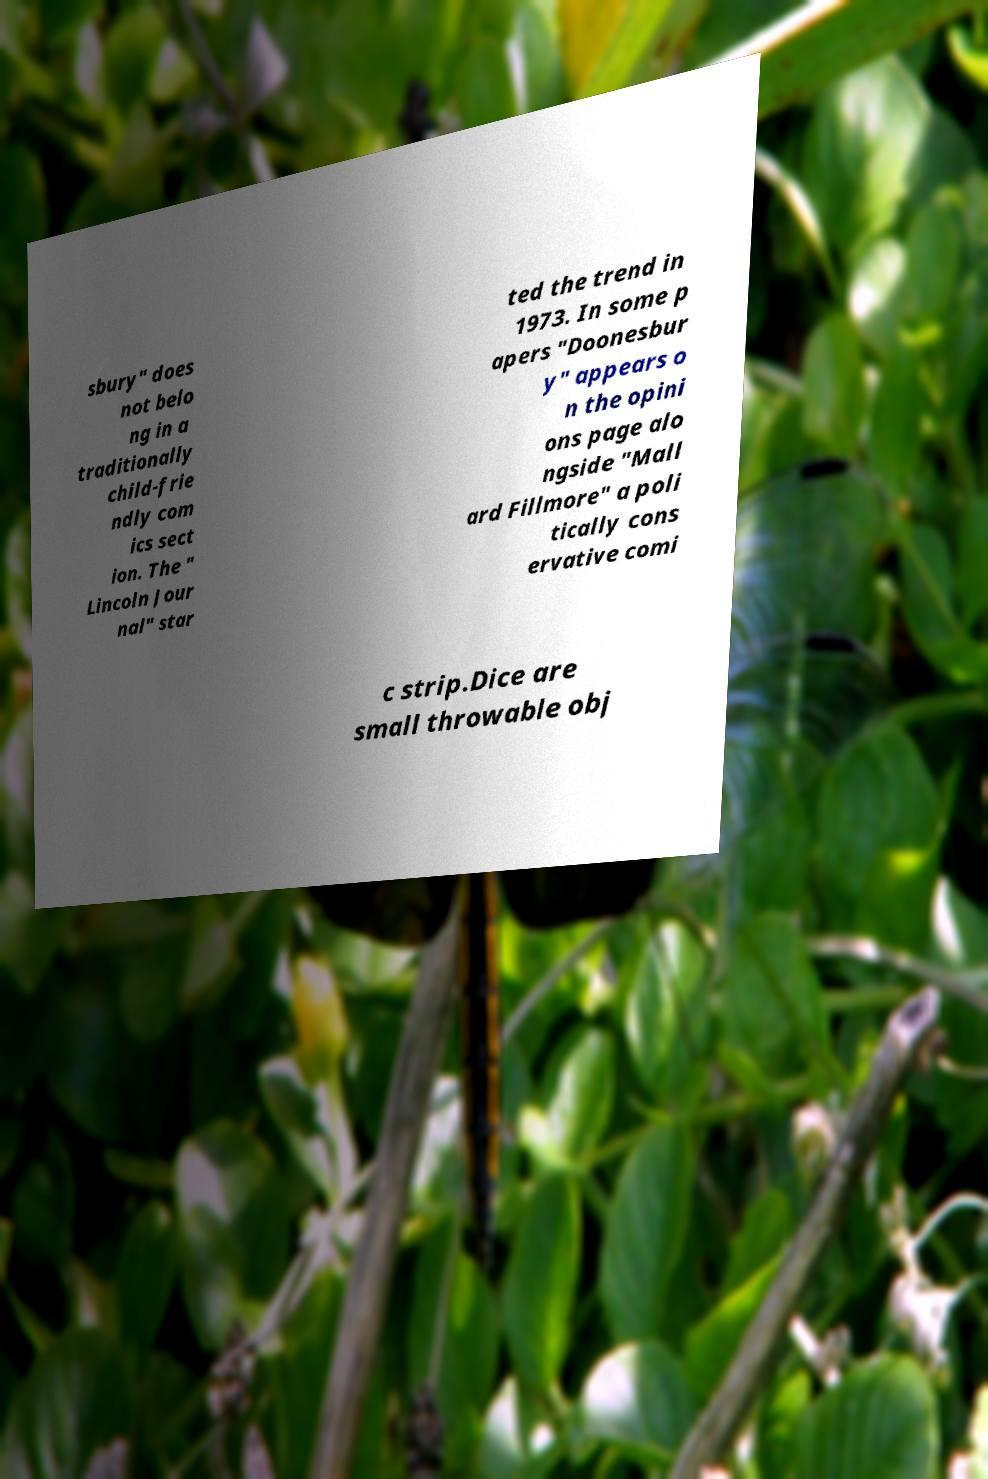Can you accurately transcribe the text from the provided image for me? sbury" does not belo ng in a traditionally child-frie ndly com ics sect ion. The " Lincoln Jour nal" star ted the trend in 1973. In some p apers "Doonesbur y" appears o n the opini ons page alo ngside "Mall ard Fillmore" a poli tically cons ervative comi c strip.Dice are small throwable obj 